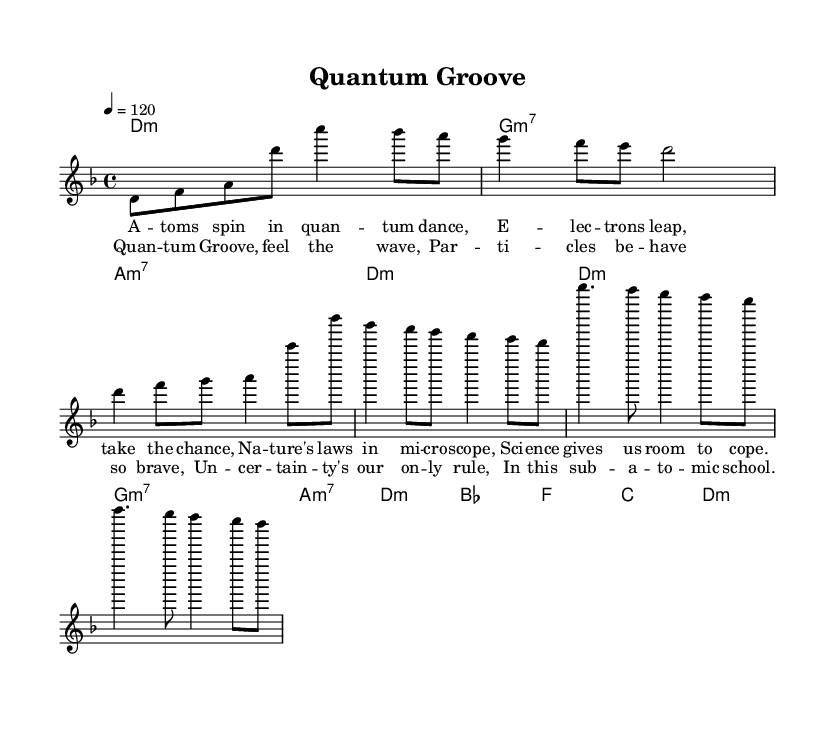What is the key signature of this music? The key signature is D minor, which has one flat (B flat). This can be determined by looking at the key signature in the beginning of the piece, which visually shows one flat.
Answer: D minor What is the time signature of this piece? The time signature is 4/4, which indicates that there are four beats in each measure and a quarter note gets one beat. This is found at the beginning of the score, where the time signature is displayed.
Answer: 4/4 What is the tempo marking of this composition? The tempo marking is 120 beats per minute, indicated at the start of the score. It tells the performer how fast the piece should be played.
Answer: 120 What type of chords are used in the intros and verses? The chords in the intros and verses are minor chords, as seen in the chord progression provided. Each of the chords has a specification of minor (e.g., d minor, g minor 7, a minor 7).
Answer: Minor How many measures are in the chorus section? The chorus contains four measures, which can be counted by identifying the groupings of notes and chords within the chorus lyrics and accompanying melody. Each set of lyric lines corresponds to one measure.
Answer: Four What is the main theme of the lyrics? The main theme of the lyrics focuses on quantum physics and its relation to nature and science. The lyrics mention particles and uncertainty, suggesting a scientific educational theme.
Answer: Quantum physics What unique musical elements can be found in jazz-rock fusion that appear in this piece? The unique elements include complex rhythms and harmonies, and the incorporation of jazz chords like minor 7ths, along with a rock tempo. These characteristics can be inferred from the structure and style of the piece.
Answer: Complex rhythms 